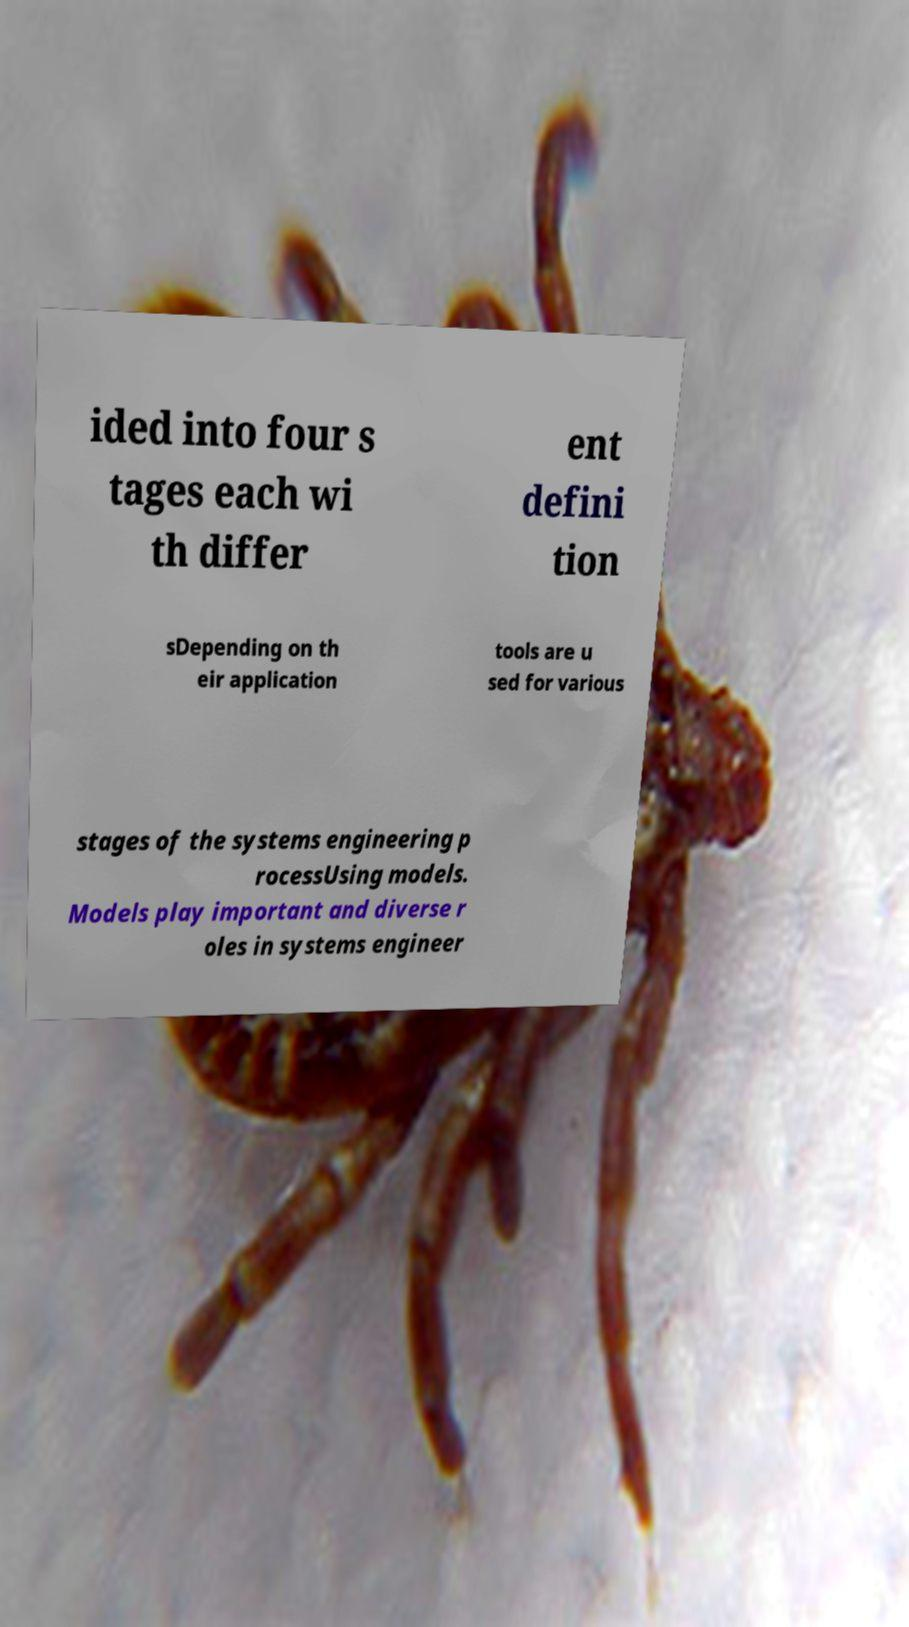Can you accurately transcribe the text from the provided image for me? ided into four s tages each wi th differ ent defini tion sDepending on th eir application tools are u sed for various stages of the systems engineering p rocessUsing models. Models play important and diverse r oles in systems engineer 